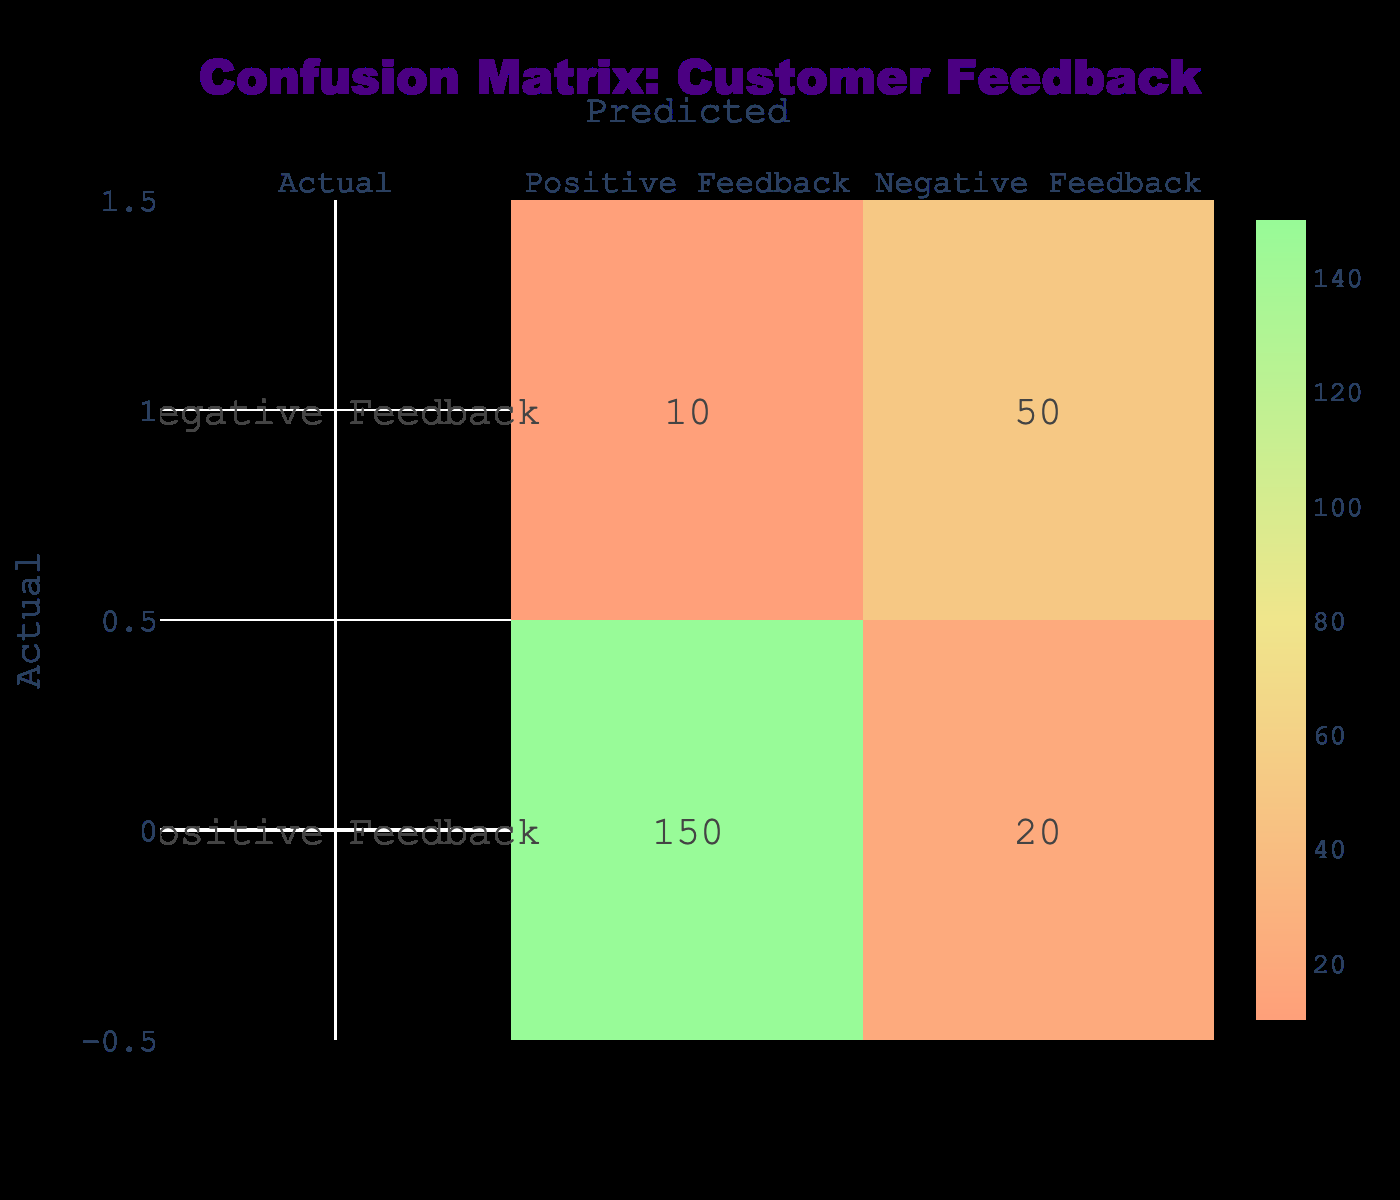What is the total number of positive feedbacks received? From the table, we look at the row labeled "Positive Feedback". Adding the values under "Positive Feedback," we find 150 positive responses.
Answer: 150 What is the total number of negative feedbacks received? Looking at the row labeled "Negative Feedback", we add the values under "Negative Feedback," which gives us 50.
Answer: 50 How many instances were misclassified as negative feedback when the feedback was actually positive? To find this, we look at the intersection of "Positive Feedback" under "Actual" and "Negative Feedback" under "Predicted." This shows 20 instances were misclassified.
Answer: 20 What is the total number of feedbacks collected? We sum all the entries in the table: (150 + 20 + 10 + 50) = 230. This represents the total feedback received.
Answer: 230 Is the number of actual negative feedbacks higher than the number of misclassified positive feedbacks? The actual negative feedbacks show 50; the misclassified positive feedbacks are 20. Since 50 is greater than 20, the statement is true.
Answer: Yes What percentage of positive feedback was correctly classified as positive? To find this, we take the number of true positive instances (150) and divide by the total number of positive instances (150 + 20). This results in (150 / 170) * 100 = approximately 88.24%.
Answer: 88.24% How many more positive feedbacks were correctly classified compared to negative feedbacks? The correct classification numbers are 150 (positive) and 50 (negative). The difference is 150 - 50 = 100.
Answer: 100 If a customer provides feedback, what is the likelihood it is positive based on this data? To calculate this, we take the total of positive feedbacks (150) and divide by the total feedbacks (230), giving us 150 / 230, which approximates to 0.652, or 65.2%.
Answer: 65.2% 